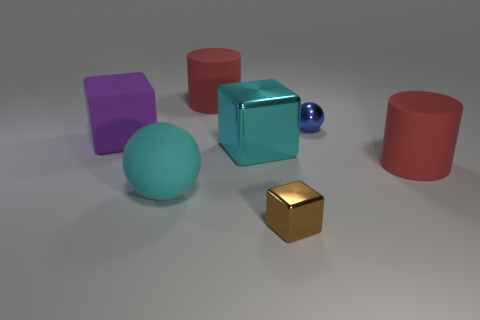What size is the red object that is left of the red rubber thing in front of the purple cube?
Make the answer very short. Large. There is a metallic ball; does it have the same color as the rubber object that is behind the purple object?
Give a very brief answer. No. There is a matte ball; how many large cyan matte things are on the right side of it?
Give a very brief answer. 0. Is the number of large cyan rubber spheres less than the number of small gray spheres?
Provide a succinct answer. No. There is a matte object that is to the left of the blue ball and in front of the big cyan shiny block; what size is it?
Make the answer very short. Large. Does the object that is on the right side of the metal ball have the same color as the tiny metal sphere?
Give a very brief answer. No. Are there fewer tiny metallic cubes that are in front of the big purple matte thing than purple metal balls?
Give a very brief answer. No. There is a purple thing that is the same material as the big ball; what shape is it?
Keep it short and to the point. Cube. Do the big cyan cube and the purple object have the same material?
Offer a very short reply. No. Is the number of big cyan shiny objects on the right side of the small block less than the number of brown objects in front of the matte sphere?
Make the answer very short. Yes. 